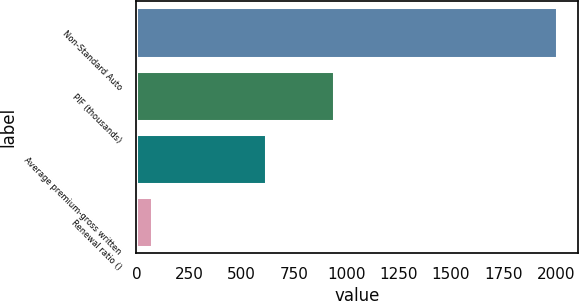Convert chart to OTSL. <chart><loc_0><loc_0><loc_500><loc_500><bar_chart><fcel>Non-Standard Auto<fcel>PIF (thousands)<fcel>Average premium-gross written<fcel>Renewal ratio ()<nl><fcel>2006<fcel>943<fcel>617<fcel>75.9<nl></chart> 